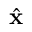<formula> <loc_0><loc_0><loc_500><loc_500>\hat { x }</formula> 